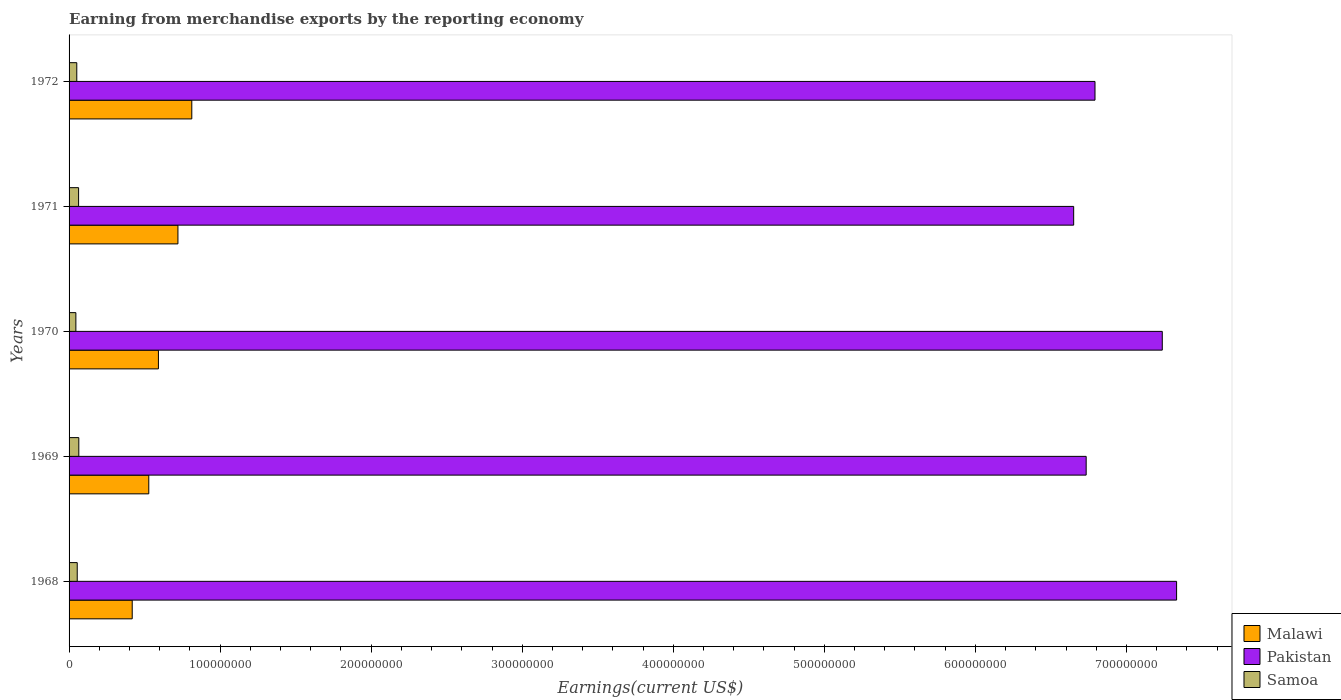How many different coloured bars are there?
Ensure brevity in your answer.  3. What is the label of the 5th group of bars from the top?
Your answer should be very brief. 1968. In how many cases, is the number of bars for a given year not equal to the number of legend labels?
Your answer should be very brief. 0. What is the amount earned from merchandise exports in Samoa in 1971?
Give a very brief answer. 6.30e+06. Across all years, what is the maximum amount earned from merchandise exports in Malawi?
Provide a short and direct response. 8.13e+07. Across all years, what is the minimum amount earned from merchandise exports in Samoa?
Offer a very short reply. 4.50e+06. In which year was the amount earned from merchandise exports in Pakistan maximum?
Your answer should be very brief. 1968. In which year was the amount earned from merchandise exports in Malawi minimum?
Provide a succinct answer. 1968. What is the total amount earned from merchandise exports in Samoa in the graph?
Your response must be concise. 2.77e+07. What is the difference between the amount earned from merchandise exports in Pakistan in 1969 and that in 1971?
Your answer should be very brief. 8.28e+06. What is the difference between the amount earned from merchandise exports in Samoa in 1971 and the amount earned from merchandise exports in Malawi in 1969?
Offer a very short reply. -4.65e+07. What is the average amount earned from merchandise exports in Pakistan per year?
Your response must be concise. 6.95e+08. In the year 1968, what is the difference between the amount earned from merchandise exports in Malawi and amount earned from merchandise exports in Pakistan?
Your answer should be compact. -6.91e+08. What is the ratio of the amount earned from merchandise exports in Pakistan in 1968 to that in 1969?
Make the answer very short. 1.09. Is the difference between the amount earned from merchandise exports in Malawi in 1969 and 1972 greater than the difference between the amount earned from merchandise exports in Pakistan in 1969 and 1972?
Offer a terse response. No. What is the difference between the highest and the second highest amount earned from merchandise exports in Pakistan?
Your answer should be very brief. 9.48e+06. What is the difference between the highest and the lowest amount earned from merchandise exports in Malawi?
Give a very brief answer. 3.95e+07. Is the sum of the amount earned from merchandise exports in Samoa in 1968 and 1970 greater than the maximum amount earned from merchandise exports in Pakistan across all years?
Give a very brief answer. No. What does the 1st bar from the top in 1969 represents?
Provide a short and direct response. Samoa. What does the 1st bar from the bottom in 1971 represents?
Your answer should be very brief. Malawi. What is the difference between two consecutive major ticks on the X-axis?
Give a very brief answer. 1.00e+08. How are the legend labels stacked?
Make the answer very short. Vertical. What is the title of the graph?
Provide a short and direct response. Earning from merchandise exports by the reporting economy. Does "Belgium" appear as one of the legend labels in the graph?
Ensure brevity in your answer.  No. What is the label or title of the X-axis?
Provide a succinct answer. Earnings(current US$). What is the label or title of the Y-axis?
Your answer should be compact. Years. What is the Earnings(current US$) of Malawi in 1968?
Keep it short and to the point. 4.18e+07. What is the Earnings(current US$) of Pakistan in 1968?
Your answer should be very brief. 7.33e+08. What is the Earnings(current US$) of Samoa in 1968?
Your answer should be very brief. 5.40e+06. What is the Earnings(current US$) in Malawi in 1969?
Make the answer very short. 5.28e+07. What is the Earnings(current US$) of Pakistan in 1969?
Your response must be concise. 6.73e+08. What is the Earnings(current US$) in Samoa in 1969?
Your answer should be compact. 6.44e+06. What is the Earnings(current US$) of Malawi in 1970?
Your answer should be very brief. 5.92e+07. What is the Earnings(current US$) of Pakistan in 1970?
Keep it short and to the point. 7.24e+08. What is the Earnings(current US$) of Samoa in 1970?
Give a very brief answer. 4.50e+06. What is the Earnings(current US$) of Malawi in 1971?
Your response must be concise. 7.21e+07. What is the Earnings(current US$) of Pakistan in 1971?
Offer a very short reply. 6.65e+08. What is the Earnings(current US$) in Samoa in 1971?
Offer a very short reply. 6.30e+06. What is the Earnings(current US$) in Malawi in 1972?
Make the answer very short. 8.13e+07. What is the Earnings(current US$) in Pakistan in 1972?
Your response must be concise. 6.79e+08. What is the Earnings(current US$) of Samoa in 1972?
Keep it short and to the point. 5.10e+06. Across all years, what is the maximum Earnings(current US$) in Malawi?
Make the answer very short. 8.13e+07. Across all years, what is the maximum Earnings(current US$) of Pakistan?
Offer a very short reply. 7.33e+08. Across all years, what is the maximum Earnings(current US$) in Samoa?
Your response must be concise. 6.44e+06. Across all years, what is the minimum Earnings(current US$) in Malawi?
Keep it short and to the point. 4.18e+07. Across all years, what is the minimum Earnings(current US$) of Pakistan?
Offer a very short reply. 6.65e+08. Across all years, what is the minimum Earnings(current US$) in Samoa?
Offer a terse response. 4.50e+06. What is the total Earnings(current US$) in Malawi in the graph?
Provide a short and direct response. 3.07e+08. What is the total Earnings(current US$) in Pakistan in the graph?
Provide a succinct answer. 3.47e+09. What is the total Earnings(current US$) in Samoa in the graph?
Ensure brevity in your answer.  2.77e+07. What is the difference between the Earnings(current US$) in Malawi in 1968 and that in 1969?
Ensure brevity in your answer.  -1.10e+07. What is the difference between the Earnings(current US$) in Pakistan in 1968 and that in 1969?
Your answer should be very brief. 5.99e+07. What is the difference between the Earnings(current US$) of Samoa in 1968 and that in 1969?
Your response must be concise. -1.04e+06. What is the difference between the Earnings(current US$) of Malawi in 1968 and that in 1970?
Give a very brief answer. -1.74e+07. What is the difference between the Earnings(current US$) in Pakistan in 1968 and that in 1970?
Your answer should be compact. 9.48e+06. What is the difference between the Earnings(current US$) of Samoa in 1968 and that in 1970?
Offer a terse response. 9.00e+05. What is the difference between the Earnings(current US$) in Malawi in 1968 and that in 1971?
Provide a short and direct response. -3.03e+07. What is the difference between the Earnings(current US$) in Pakistan in 1968 and that in 1971?
Keep it short and to the point. 6.81e+07. What is the difference between the Earnings(current US$) in Samoa in 1968 and that in 1971?
Make the answer very short. -9.00e+05. What is the difference between the Earnings(current US$) in Malawi in 1968 and that in 1972?
Offer a very short reply. -3.95e+07. What is the difference between the Earnings(current US$) of Pakistan in 1968 and that in 1972?
Keep it short and to the point. 5.40e+07. What is the difference between the Earnings(current US$) of Malawi in 1969 and that in 1970?
Your answer should be very brief. -6.38e+06. What is the difference between the Earnings(current US$) in Pakistan in 1969 and that in 1970?
Your answer should be compact. -5.04e+07. What is the difference between the Earnings(current US$) of Samoa in 1969 and that in 1970?
Keep it short and to the point. 1.94e+06. What is the difference between the Earnings(current US$) in Malawi in 1969 and that in 1971?
Give a very brief answer. -1.93e+07. What is the difference between the Earnings(current US$) of Pakistan in 1969 and that in 1971?
Keep it short and to the point. 8.28e+06. What is the difference between the Earnings(current US$) of Samoa in 1969 and that in 1971?
Offer a terse response. 1.44e+05. What is the difference between the Earnings(current US$) in Malawi in 1969 and that in 1972?
Your answer should be very brief. -2.85e+07. What is the difference between the Earnings(current US$) of Pakistan in 1969 and that in 1972?
Offer a terse response. -5.84e+06. What is the difference between the Earnings(current US$) of Samoa in 1969 and that in 1972?
Your answer should be very brief. 1.34e+06. What is the difference between the Earnings(current US$) in Malawi in 1970 and that in 1971?
Your response must be concise. -1.29e+07. What is the difference between the Earnings(current US$) in Pakistan in 1970 and that in 1971?
Your answer should be compact. 5.87e+07. What is the difference between the Earnings(current US$) of Samoa in 1970 and that in 1971?
Provide a short and direct response. -1.80e+06. What is the difference between the Earnings(current US$) in Malawi in 1970 and that in 1972?
Keep it short and to the point. -2.21e+07. What is the difference between the Earnings(current US$) in Pakistan in 1970 and that in 1972?
Give a very brief answer. 4.45e+07. What is the difference between the Earnings(current US$) of Samoa in 1970 and that in 1972?
Give a very brief answer. -6.00e+05. What is the difference between the Earnings(current US$) in Malawi in 1971 and that in 1972?
Offer a very short reply. -9.18e+06. What is the difference between the Earnings(current US$) of Pakistan in 1971 and that in 1972?
Make the answer very short. -1.41e+07. What is the difference between the Earnings(current US$) in Samoa in 1971 and that in 1972?
Offer a terse response. 1.20e+06. What is the difference between the Earnings(current US$) of Malawi in 1968 and the Earnings(current US$) of Pakistan in 1969?
Your answer should be very brief. -6.32e+08. What is the difference between the Earnings(current US$) of Malawi in 1968 and the Earnings(current US$) of Samoa in 1969?
Make the answer very short. 3.54e+07. What is the difference between the Earnings(current US$) in Pakistan in 1968 and the Earnings(current US$) in Samoa in 1969?
Provide a short and direct response. 7.27e+08. What is the difference between the Earnings(current US$) of Malawi in 1968 and the Earnings(current US$) of Pakistan in 1970?
Provide a short and direct response. -6.82e+08. What is the difference between the Earnings(current US$) of Malawi in 1968 and the Earnings(current US$) of Samoa in 1970?
Your response must be concise. 3.73e+07. What is the difference between the Earnings(current US$) in Pakistan in 1968 and the Earnings(current US$) in Samoa in 1970?
Give a very brief answer. 7.29e+08. What is the difference between the Earnings(current US$) of Malawi in 1968 and the Earnings(current US$) of Pakistan in 1971?
Your response must be concise. -6.23e+08. What is the difference between the Earnings(current US$) in Malawi in 1968 and the Earnings(current US$) in Samoa in 1971?
Your answer should be compact. 3.55e+07. What is the difference between the Earnings(current US$) of Pakistan in 1968 and the Earnings(current US$) of Samoa in 1971?
Provide a short and direct response. 7.27e+08. What is the difference between the Earnings(current US$) in Malawi in 1968 and the Earnings(current US$) in Pakistan in 1972?
Your response must be concise. -6.37e+08. What is the difference between the Earnings(current US$) of Malawi in 1968 and the Earnings(current US$) of Samoa in 1972?
Your answer should be compact. 3.67e+07. What is the difference between the Earnings(current US$) in Pakistan in 1968 and the Earnings(current US$) in Samoa in 1972?
Your answer should be very brief. 7.28e+08. What is the difference between the Earnings(current US$) of Malawi in 1969 and the Earnings(current US$) of Pakistan in 1970?
Your response must be concise. -6.71e+08. What is the difference between the Earnings(current US$) in Malawi in 1969 and the Earnings(current US$) in Samoa in 1970?
Your answer should be very brief. 4.83e+07. What is the difference between the Earnings(current US$) of Pakistan in 1969 and the Earnings(current US$) of Samoa in 1970?
Give a very brief answer. 6.69e+08. What is the difference between the Earnings(current US$) of Malawi in 1969 and the Earnings(current US$) of Pakistan in 1971?
Offer a terse response. -6.12e+08. What is the difference between the Earnings(current US$) in Malawi in 1969 and the Earnings(current US$) in Samoa in 1971?
Your response must be concise. 4.65e+07. What is the difference between the Earnings(current US$) in Pakistan in 1969 and the Earnings(current US$) in Samoa in 1971?
Give a very brief answer. 6.67e+08. What is the difference between the Earnings(current US$) in Malawi in 1969 and the Earnings(current US$) in Pakistan in 1972?
Give a very brief answer. -6.26e+08. What is the difference between the Earnings(current US$) of Malawi in 1969 and the Earnings(current US$) of Samoa in 1972?
Provide a succinct answer. 4.77e+07. What is the difference between the Earnings(current US$) in Pakistan in 1969 and the Earnings(current US$) in Samoa in 1972?
Offer a terse response. 6.68e+08. What is the difference between the Earnings(current US$) in Malawi in 1970 and the Earnings(current US$) in Pakistan in 1971?
Ensure brevity in your answer.  -6.06e+08. What is the difference between the Earnings(current US$) in Malawi in 1970 and the Earnings(current US$) in Samoa in 1971?
Offer a terse response. 5.28e+07. What is the difference between the Earnings(current US$) of Pakistan in 1970 and the Earnings(current US$) of Samoa in 1971?
Your answer should be compact. 7.17e+08. What is the difference between the Earnings(current US$) in Malawi in 1970 and the Earnings(current US$) in Pakistan in 1972?
Offer a very short reply. -6.20e+08. What is the difference between the Earnings(current US$) of Malawi in 1970 and the Earnings(current US$) of Samoa in 1972?
Your response must be concise. 5.40e+07. What is the difference between the Earnings(current US$) in Pakistan in 1970 and the Earnings(current US$) in Samoa in 1972?
Ensure brevity in your answer.  7.19e+08. What is the difference between the Earnings(current US$) in Malawi in 1971 and the Earnings(current US$) in Pakistan in 1972?
Your answer should be compact. -6.07e+08. What is the difference between the Earnings(current US$) in Malawi in 1971 and the Earnings(current US$) in Samoa in 1972?
Provide a succinct answer. 6.70e+07. What is the difference between the Earnings(current US$) in Pakistan in 1971 and the Earnings(current US$) in Samoa in 1972?
Provide a short and direct response. 6.60e+08. What is the average Earnings(current US$) of Malawi per year?
Make the answer very short. 6.14e+07. What is the average Earnings(current US$) of Pakistan per year?
Your response must be concise. 6.95e+08. What is the average Earnings(current US$) in Samoa per year?
Your response must be concise. 5.55e+06. In the year 1968, what is the difference between the Earnings(current US$) of Malawi and Earnings(current US$) of Pakistan?
Your answer should be compact. -6.91e+08. In the year 1968, what is the difference between the Earnings(current US$) of Malawi and Earnings(current US$) of Samoa?
Provide a succinct answer. 3.64e+07. In the year 1968, what is the difference between the Earnings(current US$) in Pakistan and Earnings(current US$) in Samoa?
Provide a short and direct response. 7.28e+08. In the year 1969, what is the difference between the Earnings(current US$) of Malawi and Earnings(current US$) of Pakistan?
Your answer should be very brief. -6.21e+08. In the year 1969, what is the difference between the Earnings(current US$) in Malawi and Earnings(current US$) in Samoa?
Your answer should be compact. 4.63e+07. In the year 1969, what is the difference between the Earnings(current US$) in Pakistan and Earnings(current US$) in Samoa?
Provide a short and direct response. 6.67e+08. In the year 1970, what is the difference between the Earnings(current US$) of Malawi and Earnings(current US$) of Pakistan?
Ensure brevity in your answer.  -6.65e+08. In the year 1970, what is the difference between the Earnings(current US$) of Malawi and Earnings(current US$) of Samoa?
Provide a succinct answer. 5.46e+07. In the year 1970, what is the difference between the Earnings(current US$) in Pakistan and Earnings(current US$) in Samoa?
Your answer should be very brief. 7.19e+08. In the year 1971, what is the difference between the Earnings(current US$) in Malawi and Earnings(current US$) in Pakistan?
Keep it short and to the point. -5.93e+08. In the year 1971, what is the difference between the Earnings(current US$) of Malawi and Earnings(current US$) of Samoa?
Your response must be concise. 6.58e+07. In the year 1971, what is the difference between the Earnings(current US$) of Pakistan and Earnings(current US$) of Samoa?
Offer a terse response. 6.59e+08. In the year 1972, what is the difference between the Earnings(current US$) in Malawi and Earnings(current US$) in Pakistan?
Make the answer very short. -5.98e+08. In the year 1972, what is the difference between the Earnings(current US$) of Malawi and Earnings(current US$) of Samoa?
Offer a very short reply. 7.62e+07. In the year 1972, what is the difference between the Earnings(current US$) of Pakistan and Earnings(current US$) of Samoa?
Keep it short and to the point. 6.74e+08. What is the ratio of the Earnings(current US$) of Malawi in 1968 to that in 1969?
Offer a terse response. 0.79. What is the ratio of the Earnings(current US$) in Pakistan in 1968 to that in 1969?
Make the answer very short. 1.09. What is the ratio of the Earnings(current US$) in Samoa in 1968 to that in 1969?
Provide a succinct answer. 0.84. What is the ratio of the Earnings(current US$) of Malawi in 1968 to that in 1970?
Make the answer very short. 0.71. What is the ratio of the Earnings(current US$) in Pakistan in 1968 to that in 1970?
Provide a short and direct response. 1.01. What is the ratio of the Earnings(current US$) of Malawi in 1968 to that in 1971?
Provide a short and direct response. 0.58. What is the ratio of the Earnings(current US$) of Pakistan in 1968 to that in 1971?
Give a very brief answer. 1.1. What is the ratio of the Earnings(current US$) in Samoa in 1968 to that in 1971?
Provide a short and direct response. 0.86. What is the ratio of the Earnings(current US$) of Malawi in 1968 to that in 1972?
Provide a succinct answer. 0.51. What is the ratio of the Earnings(current US$) in Pakistan in 1968 to that in 1972?
Keep it short and to the point. 1.08. What is the ratio of the Earnings(current US$) of Samoa in 1968 to that in 1972?
Offer a terse response. 1.06. What is the ratio of the Earnings(current US$) in Malawi in 1969 to that in 1970?
Make the answer very short. 0.89. What is the ratio of the Earnings(current US$) in Pakistan in 1969 to that in 1970?
Provide a short and direct response. 0.93. What is the ratio of the Earnings(current US$) of Samoa in 1969 to that in 1970?
Ensure brevity in your answer.  1.43. What is the ratio of the Earnings(current US$) in Malawi in 1969 to that in 1971?
Give a very brief answer. 0.73. What is the ratio of the Earnings(current US$) of Pakistan in 1969 to that in 1971?
Your answer should be very brief. 1.01. What is the ratio of the Earnings(current US$) in Samoa in 1969 to that in 1971?
Provide a short and direct response. 1.02. What is the ratio of the Earnings(current US$) of Malawi in 1969 to that in 1972?
Provide a short and direct response. 0.65. What is the ratio of the Earnings(current US$) of Samoa in 1969 to that in 1972?
Your answer should be compact. 1.26. What is the ratio of the Earnings(current US$) of Malawi in 1970 to that in 1971?
Provide a succinct answer. 0.82. What is the ratio of the Earnings(current US$) in Pakistan in 1970 to that in 1971?
Provide a succinct answer. 1.09. What is the ratio of the Earnings(current US$) of Samoa in 1970 to that in 1971?
Provide a succinct answer. 0.71. What is the ratio of the Earnings(current US$) of Malawi in 1970 to that in 1972?
Give a very brief answer. 0.73. What is the ratio of the Earnings(current US$) in Pakistan in 1970 to that in 1972?
Keep it short and to the point. 1.07. What is the ratio of the Earnings(current US$) in Samoa in 1970 to that in 1972?
Provide a succinct answer. 0.88. What is the ratio of the Earnings(current US$) of Malawi in 1971 to that in 1972?
Make the answer very short. 0.89. What is the ratio of the Earnings(current US$) in Pakistan in 1971 to that in 1972?
Provide a succinct answer. 0.98. What is the ratio of the Earnings(current US$) in Samoa in 1971 to that in 1972?
Keep it short and to the point. 1.24. What is the difference between the highest and the second highest Earnings(current US$) of Malawi?
Your answer should be very brief. 9.18e+06. What is the difference between the highest and the second highest Earnings(current US$) of Pakistan?
Provide a short and direct response. 9.48e+06. What is the difference between the highest and the second highest Earnings(current US$) in Samoa?
Provide a short and direct response. 1.44e+05. What is the difference between the highest and the lowest Earnings(current US$) of Malawi?
Provide a short and direct response. 3.95e+07. What is the difference between the highest and the lowest Earnings(current US$) of Pakistan?
Provide a short and direct response. 6.81e+07. What is the difference between the highest and the lowest Earnings(current US$) of Samoa?
Ensure brevity in your answer.  1.94e+06. 